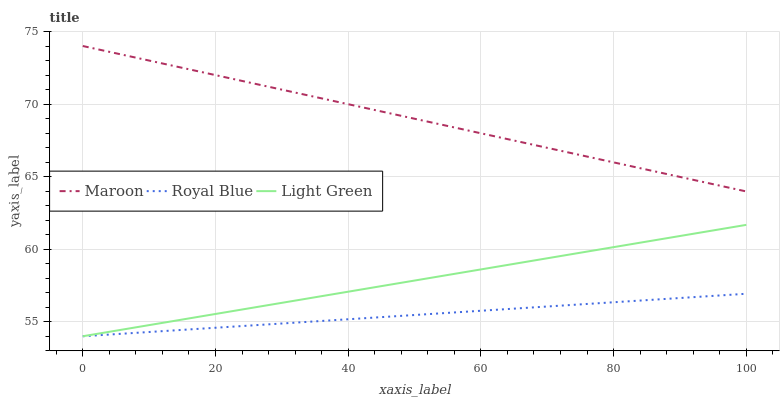Does Royal Blue have the minimum area under the curve?
Answer yes or no. Yes. Does Maroon have the maximum area under the curve?
Answer yes or no. Yes. Does Light Green have the minimum area under the curve?
Answer yes or no. No. Does Light Green have the maximum area under the curve?
Answer yes or no. No. Is Light Green the smoothest?
Answer yes or no. Yes. Is Maroon the roughest?
Answer yes or no. Yes. Is Maroon the smoothest?
Answer yes or no. No. Is Light Green the roughest?
Answer yes or no. No. Does Royal Blue have the lowest value?
Answer yes or no. Yes. Does Maroon have the lowest value?
Answer yes or no. No. Does Maroon have the highest value?
Answer yes or no. Yes. Does Light Green have the highest value?
Answer yes or no. No. Is Light Green less than Maroon?
Answer yes or no. Yes. Is Maroon greater than Royal Blue?
Answer yes or no. Yes. Does Light Green intersect Royal Blue?
Answer yes or no. Yes. Is Light Green less than Royal Blue?
Answer yes or no. No. Is Light Green greater than Royal Blue?
Answer yes or no. No. Does Light Green intersect Maroon?
Answer yes or no. No. 